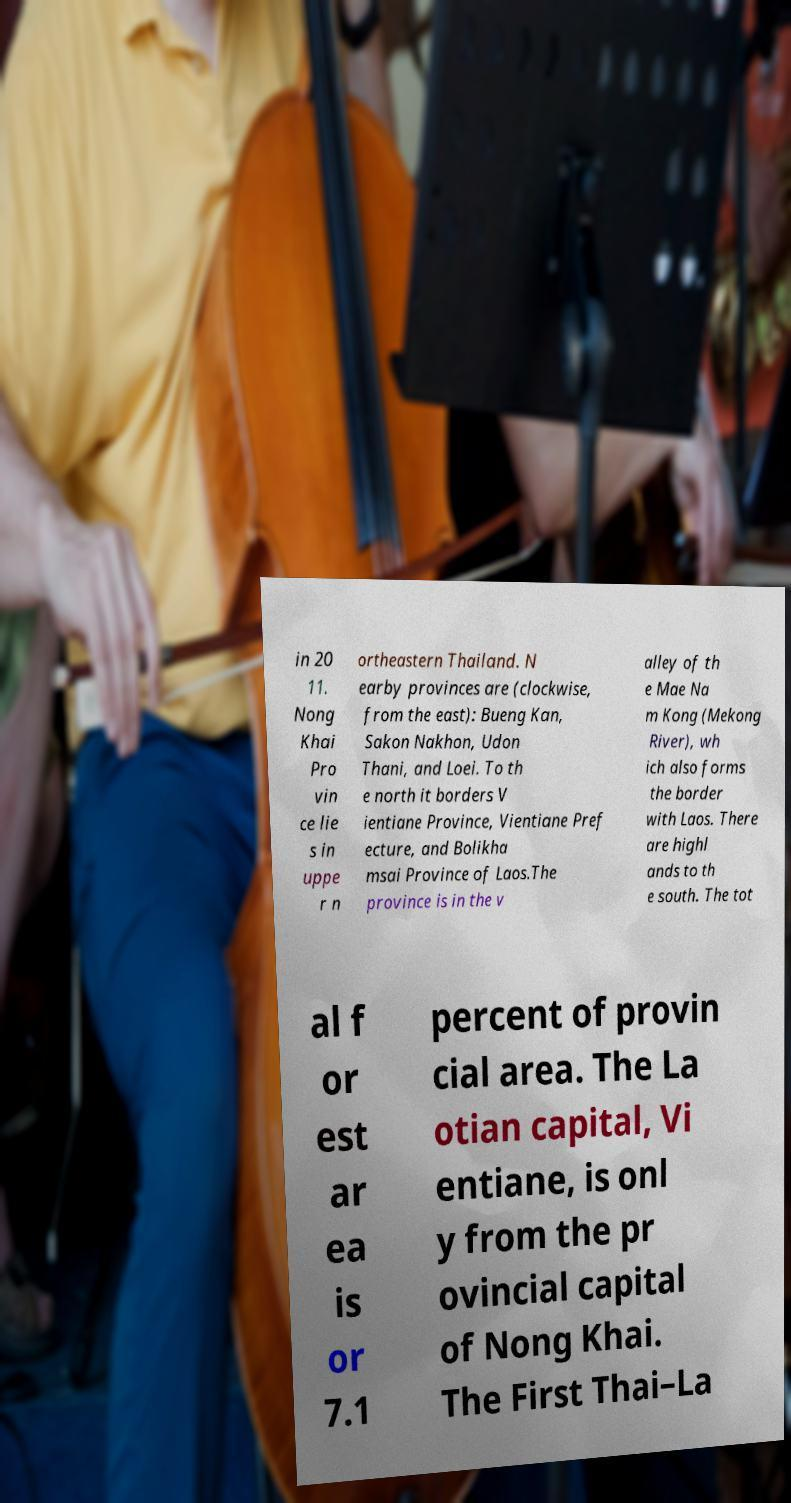I need the written content from this picture converted into text. Can you do that? in 20 11. Nong Khai Pro vin ce lie s in uppe r n ortheastern Thailand. N earby provinces are (clockwise, from the east): Bueng Kan, Sakon Nakhon, Udon Thani, and Loei. To th e north it borders V ientiane Province, Vientiane Pref ecture, and Bolikha msai Province of Laos.The province is in the v alley of th e Mae Na m Kong (Mekong River), wh ich also forms the border with Laos. There are highl ands to th e south. The tot al f or est ar ea is or 7.1 percent of provin cial area. The La otian capital, Vi entiane, is onl y from the pr ovincial capital of Nong Khai. The First Thai–La 